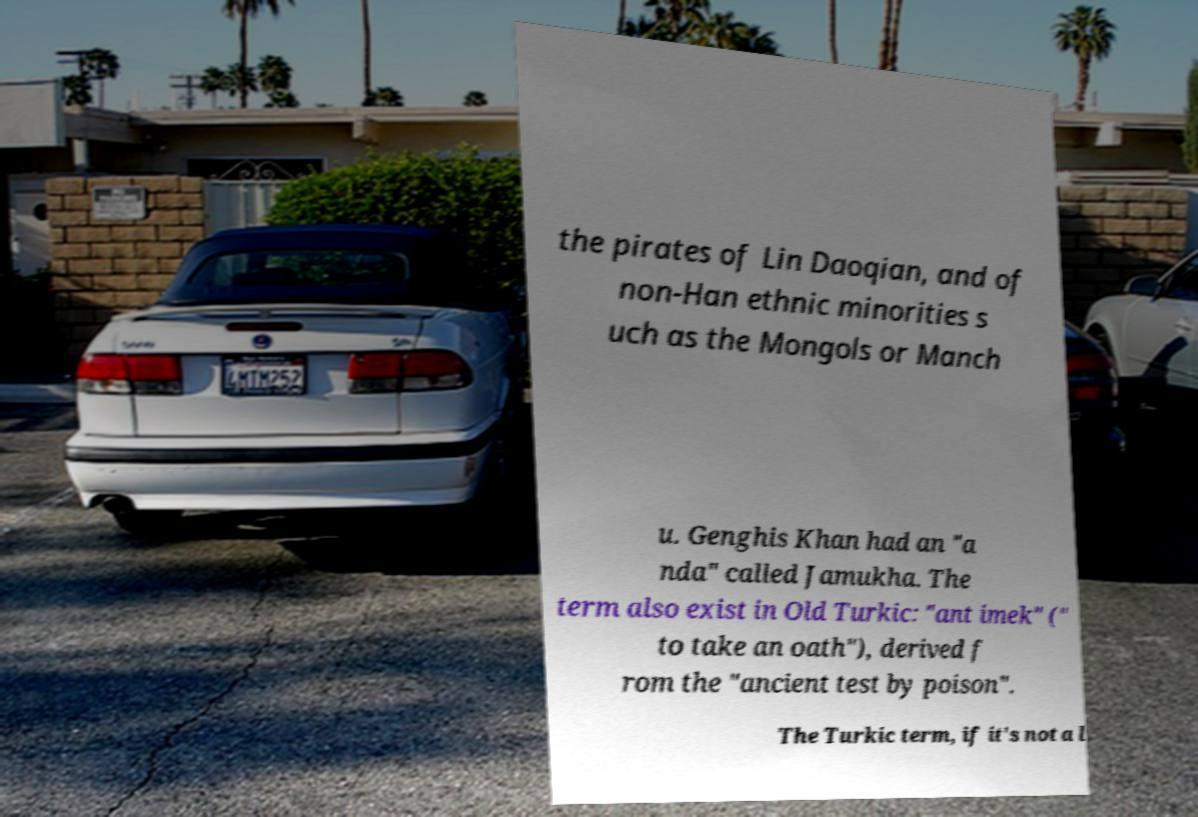There's text embedded in this image that I need extracted. Can you transcribe it verbatim? the pirates of Lin Daoqian, and of non-Han ethnic minorities s uch as the Mongols or Manch u. Genghis Khan had an "a nda" called Jamukha. The term also exist in Old Turkic: "ant imek" (" to take an oath"), derived f rom the "ancient test by poison". The Turkic term, if it's not a l 